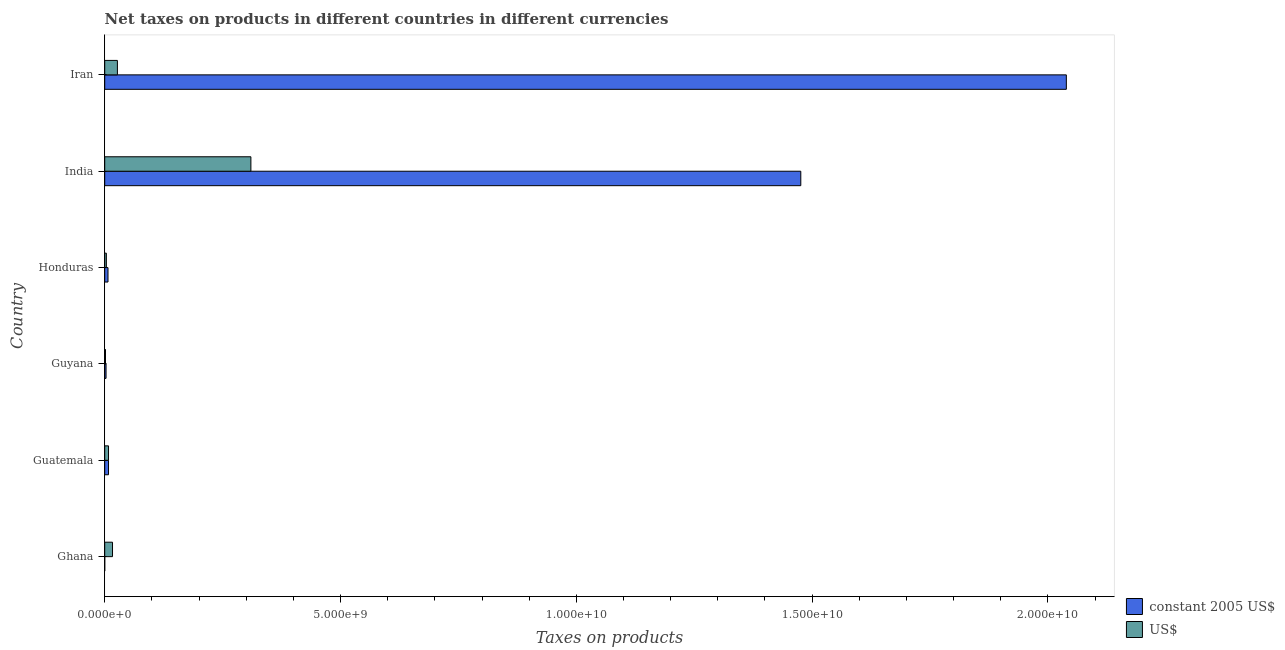How many different coloured bars are there?
Keep it short and to the point. 2. How many groups of bars are there?
Your answer should be very brief. 6. Are the number of bars per tick equal to the number of legend labels?
Provide a succinct answer. Yes. How many bars are there on the 5th tick from the top?
Provide a short and direct response. 2. What is the label of the 5th group of bars from the top?
Ensure brevity in your answer.  Guatemala. In how many cases, is the number of bars for a given country not equal to the number of legend labels?
Offer a terse response. 0. What is the net taxes in constant 2005 us$ in Ghana?
Provide a succinct answer. 1.18e+04. Across all countries, what is the maximum net taxes in us$?
Provide a succinct answer. 3.10e+09. Across all countries, what is the minimum net taxes in constant 2005 us$?
Your response must be concise. 1.18e+04. In which country was the net taxes in constant 2005 us$ maximum?
Your response must be concise. Iran. In which country was the net taxes in constant 2005 us$ minimum?
Offer a terse response. Ghana. What is the total net taxes in us$ in the graph?
Make the answer very short. 3.67e+09. What is the difference between the net taxes in constant 2005 us$ in Ghana and that in Honduras?
Your answer should be very brief. -6.96e+07. What is the difference between the net taxes in us$ in Guatemala and the net taxes in constant 2005 us$ in Guyana?
Ensure brevity in your answer.  5.24e+07. What is the average net taxes in constant 2005 us$ per country?
Your answer should be very brief. 5.89e+09. What is the difference between the net taxes in constant 2005 us$ and net taxes in us$ in Guyana?
Offer a very short reply. 1.18e+07. In how many countries, is the net taxes in constant 2005 us$ greater than 19000000000 units?
Provide a short and direct response. 1. What is the ratio of the net taxes in us$ in Guatemala to that in Honduras?
Keep it short and to the point. 2.32. Is the net taxes in us$ in Ghana less than that in Guyana?
Provide a short and direct response. No. What is the difference between the highest and the second highest net taxes in constant 2005 us$?
Provide a succinct answer. 5.63e+09. What is the difference between the highest and the lowest net taxes in us$?
Your answer should be very brief. 3.08e+09. In how many countries, is the net taxes in constant 2005 us$ greater than the average net taxes in constant 2005 us$ taken over all countries?
Your answer should be compact. 2. What does the 2nd bar from the top in Guatemala represents?
Offer a very short reply. Constant 2005 us$. What does the 2nd bar from the bottom in Honduras represents?
Offer a very short reply. US$. How many bars are there?
Your answer should be very brief. 12. Are all the bars in the graph horizontal?
Your response must be concise. Yes. Are the values on the major ticks of X-axis written in scientific E-notation?
Make the answer very short. Yes. Does the graph contain any zero values?
Your answer should be very brief. No. Does the graph contain grids?
Ensure brevity in your answer.  No. Where does the legend appear in the graph?
Keep it short and to the point. Bottom right. How many legend labels are there?
Offer a very short reply. 2. What is the title of the graph?
Make the answer very short. Net taxes on products in different countries in different currencies. What is the label or title of the X-axis?
Ensure brevity in your answer.  Taxes on products. What is the label or title of the Y-axis?
Your answer should be very brief. Country. What is the Taxes on products in constant 2005 US$ in Ghana?
Ensure brevity in your answer.  1.18e+04. What is the Taxes on products in US$ in Ghana?
Your answer should be very brief. 1.65e+08. What is the Taxes on products in constant 2005 US$ in Guatemala?
Provide a short and direct response. 8.06e+07. What is the Taxes on products in US$ in Guatemala?
Your response must be concise. 8.06e+07. What is the Taxes on products of constant 2005 US$ in Guyana?
Make the answer very short. 2.82e+07. What is the Taxes on products in US$ in Guyana?
Give a very brief answer. 1.64e+07. What is the Taxes on products in constant 2005 US$ in Honduras?
Make the answer very short. 6.96e+07. What is the Taxes on products in US$ in Honduras?
Offer a very short reply. 3.48e+07. What is the Taxes on products in constant 2005 US$ in India?
Provide a succinct answer. 1.48e+1. What is the Taxes on products of US$ in India?
Keep it short and to the point. 3.10e+09. What is the Taxes on products in constant 2005 US$ in Iran?
Provide a succinct answer. 2.04e+1. What is the Taxes on products in US$ in Iran?
Make the answer very short. 2.69e+08. Across all countries, what is the maximum Taxes on products of constant 2005 US$?
Keep it short and to the point. 2.04e+1. Across all countries, what is the maximum Taxes on products of US$?
Offer a terse response. 3.10e+09. Across all countries, what is the minimum Taxes on products in constant 2005 US$?
Give a very brief answer. 1.18e+04. Across all countries, what is the minimum Taxes on products in US$?
Your response must be concise. 1.64e+07. What is the total Taxes on products in constant 2005 US$ in the graph?
Ensure brevity in your answer.  3.53e+1. What is the total Taxes on products in US$ in the graph?
Provide a short and direct response. 3.67e+09. What is the difference between the Taxes on products in constant 2005 US$ in Ghana and that in Guatemala?
Your response must be concise. -8.06e+07. What is the difference between the Taxes on products in US$ in Ghana and that in Guatemala?
Make the answer very short. 8.47e+07. What is the difference between the Taxes on products of constant 2005 US$ in Ghana and that in Guyana?
Provide a short and direct response. -2.82e+07. What is the difference between the Taxes on products in US$ in Ghana and that in Guyana?
Offer a very short reply. 1.49e+08. What is the difference between the Taxes on products in constant 2005 US$ in Ghana and that in Honduras?
Keep it short and to the point. -6.96e+07. What is the difference between the Taxes on products of US$ in Ghana and that in Honduras?
Your response must be concise. 1.30e+08. What is the difference between the Taxes on products in constant 2005 US$ in Ghana and that in India?
Ensure brevity in your answer.  -1.48e+1. What is the difference between the Taxes on products of US$ in Ghana and that in India?
Give a very brief answer. -2.93e+09. What is the difference between the Taxes on products of constant 2005 US$ in Ghana and that in Iran?
Provide a short and direct response. -2.04e+1. What is the difference between the Taxes on products of US$ in Ghana and that in Iran?
Provide a succinct answer. -1.04e+08. What is the difference between the Taxes on products in constant 2005 US$ in Guatemala and that in Guyana?
Your answer should be compact. 5.24e+07. What is the difference between the Taxes on products of US$ in Guatemala and that in Guyana?
Your answer should be very brief. 6.42e+07. What is the difference between the Taxes on products in constant 2005 US$ in Guatemala and that in Honduras?
Ensure brevity in your answer.  1.10e+07. What is the difference between the Taxes on products of US$ in Guatemala and that in Honduras?
Offer a very short reply. 4.58e+07. What is the difference between the Taxes on products in constant 2005 US$ in Guatemala and that in India?
Provide a short and direct response. -1.47e+1. What is the difference between the Taxes on products in US$ in Guatemala and that in India?
Ensure brevity in your answer.  -3.02e+09. What is the difference between the Taxes on products of constant 2005 US$ in Guatemala and that in Iran?
Ensure brevity in your answer.  -2.03e+1. What is the difference between the Taxes on products of US$ in Guatemala and that in Iran?
Provide a succinct answer. -1.89e+08. What is the difference between the Taxes on products in constant 2005 US$ in Guyana and that in Honduras?
Offer a terse response. -4.14e+07. What is the difference between the Taxes on products in US$ in Guyana and that in Honduras?
Your answer should be very brief. -1.84e+07. What is the difference between the Taxes on products of constant 2005 US$ in Guyana and that in India?
Your answer should be very brief. -1.47e+1. What is the difference between the Taxes on products in US$ in Guyana and that in India?
Offer a very short reply. -3.08e+09. What is the difference between the Taxes on products of constant 2005 US$ in Guyana and that in Iran?
Make the answer very short. -2.04e+1. What is the difference between the Taxes on products in US$ in Guyana and that in Iran?
Offer a very short reply. -2.53e+08. What is the difference between the Taxes on products in constant 2005 US$ in Honduras and that in India?
Offer a terse response. -1.47e+1. What is the difference between the Taxes on products of US$ in Honduras and that in India?
Give a very brief answer. -3.06e+09. What is the difference between the Taxes on products in constant 2005 US$ in Honduras and that in Iran?
Offer a very short reply. -2.03e+1. What is the difference between the Taxes on products in US$ in Honduras and that in Iran?
Ensure brevity in your answer.  -2.34e+08. What is the difference between the Taxes on products of constant 2005 US$ in India and that in Iran?
Your response must be concise. -5.63e+09. What is the difference between the Taxes on products in US$ in India and that in Iran?
Make the answer very short. 2.83e+09. What is the difference between the Taxes on products of constant 2005 US$ in Ghana and the Taxes on products of US$ in Guatemala?
Make the answer very short. -8.06e+07. What is the difference between the Taxes on products of constant 2005 US$ in Ghana and the Taxes on products of US$ in Guyana?
Keep it short and to the point. -1.64e+07. What is the difference between the Taxes on products in constant 2005 US$ in Ghana and the Taxes on products in US$ in Honduras?
Offer a terse response. -3.48e+07. What is the difference between the Taxes on products in constant 2005 US$ in Ghana and the Taxes on products in US$ in India?
Keep it short and to the point. -3.10e+09. What is the difference between the Taxes on products in constant 2005 US$ in Ghana and the Taxes on products in US$ in Iran?
Your answer should be very brief. -2.69e+08. What is the difference between the Taxes on products in constant 2005 US$ in Guatemala and the Taxes on products in US$ in Guyana?
Keep it short and to the point. 6.42e+07. What is the difference between the Taxes on products in constant 2005 US$ in Guatemala and the Taxes on products in US$ in Honduras?
Ensure brevity in your answer.  4.58e+07. What is the difference between the Taxes on products of constant 2005 US$ in Guatemala and the Taxes on products of US$ in India?
Your answer should be very brief. -3.02e+09. What is the difference between the Taxes on products of constant 2005 US$ in Guatemala and the Taxes on products of US$ in Iran?
Your response must be concise. -1.89e+08. What is the difference between the Taxes on products in constant 2005 US$ in Guyana and the Taxes on products in US$ in Honduras?
Provide a short and direct response. -6.60e+06. What is the difference between the Taxes on products of constant 2005 US$ in Guyana and the Taxes on products of US$ in India?
Give a very brief answer. -3.07e+09. What is the difference between the Taxes on products in constant 2005 US$ in Guyana and the Taxes on products in US$ in Iran?
Provide a succinct answer. -2.41e+08. What is the difference between the Taxes on products in constant 2005 US$ in Honduras and the Taxes on products in US$ in India?
Offer a very short reply. -3.03e+09. What is the difference between the Taxes on products in constant 2005 US$ in Honduras and the Taxes on products in US$ in Iran?
Provide a succinct answer. -2.00e+08. What is the difference between the Taxes on products in constant 2005 US$ in India and the Taxes on products in US$ in Iran?
Keep it short and to the point. 1.45e+1. What is the average Taxes on products of constant 2005 US$ per country?
Keep it short and to the point. 5.89e+09. What is the average Taxes on products in US$ per country?
Your answer should be compact. 6.11e+08. What is the difference between the Taxes on products in constant 2005 US$ and Taxes on products in US$ in Ghana?
Your answer should be very brief. -1.65e+08. What is the difference between the Taxes on products of constant 2005 US$ and Taxes on products of US$ in Guatemala?
Provide a succinct answer. 0. What is the difference between the Taxes on products of constant 2005 US$ and Taxes on products of US$ in Guyana?
Make the answer very short. 1.18e+07. What is the difference between the Taxes on products in constant 2005 US$ and Taxes on products in US$ in Honduras?
Keep it short and to the point. 3.48e+07. What is the difference between the Taxes on products of constant 2005 US$ and Taxes on products of US$ in India?
Ensure brevity in your answer.  1.17e+1. What is the difference between the Taxes on products of constant 2005 US$ and Taxes on products of US$ in Iran?
Ensure brevity in your answer.  2.01e+1. What is the ratio of the Taxes on products of constant 2005 US$ in Ghana to that in Guatemala?
Give a very brief answer. 0. What is the ratio of the Taxes on products of US$ in Ghana to that in Guatemala?
Your answer should be compact. 2.05. What is the ratio of the Taxes on products of US$ in Ghana to that in Guyana?
Make the answer very short. 10.05. What is the ratio of the Taxes on products in constant 2005 US$ in Ghana to that in Honduras?
Your answer should be compact. 0. What is the ratio of the Taxes on products of US$ in Ghana to that in Honduras?
Make the answer very short. 4.75. What is the ratio of the Taxes on products of constant 2005 US$ in Ghana to that in India?
Ensure brevity in your answer.  0. What is the ratio of the Taxes on products of US$ in Ghana to that in India?
Ensure brevity in your answer.  0.05. What is the ratio of the Taxes on products of US$ in Ghana to that in Iran?
Offer a very short reply. 0.61. What is the ratio of the Taxes on products in constant 2005 US$ in Guatemala to that in Guyana?
Keep it short and to the point. 2.86. What is the ratio of the Taxes on products in US$ in Guatemala to that in Guyana?
Ensure brevity in your answer.  4.9. What is the ratio of the Taxes on products of constant 2005 US$ in Guatemala to that in Honduras?
Provide a short and direct response. 1.16. What is the ratio of the Taxes on products of US$ in Guatemala to that in Honduras?
Your answer should be very brief. 2.32. What is the ratio of the Taxes on products in constant 2005 US$ in Guatemala to that in India?
Keep it short and to the point. 0.01. What is the ratio of the Taxes on products of US$ in Guatemala to that in India?
Make the answer very short. 0.03. What is the ratio of the Taxes on products in constant 2005 US$ in Guatemala to that in Iran?
Offer a terse response. 0. What is the ratio of the Taxes on products of US$ in Guatemala to that in Iran?
Provide a succinct answer. 0.3. What is the ratio of the Taxes on products of constant 2005 US$ in Guyana to that in Honduras?
Your response must be concise. 0.41. What is the ratio of the Taxes on products in US$ in Guyana to that in Honduras?
Provide a succinct answer. 0.47. What is the ratio of the Taxes on products of constant 2005 US$ in Guyana to that in India?
Offer a terse response. 0. What is the ratio of the Taxes on products in US$ in Guyana to that in India?
Make the answer very short. 0.01. What is the ratio of the Taxes on products in constant 2005 US$ in Guyana to that in Iran?
Give a very brief answer. 0. What is the ratio of the Taxes on products in US$ in Guyana to that in Iran?
Offer a very short reply. 0.06. What is the ratio of the Taxes on products of constant 2005 US$ in Honduras to that in India?
Provide a succinct answer. 0. What is the ratio of the Taxes on products of US$ in Honduras to that in India?
Provide a succinct answer. 0.01. What is the ratio of the Taxes on products of constant 2005 US$ in Honduras to that in Iran?
Provide a succinct answer. 0. What is the ratio of the Taxes on products in US$ in Honduras to that in Iran?
Your answer should be compact. 0.13. What is the ratio of the Taxes on products of constant 2005 US$ in India to that in Iran?
Your response must be concise. 0.72. What is the ratio of the Taxes on products of US$ in India to that in Iran?
Offer a very short reply. 11.51. What is the difference between the highest and the second highest Taxes on products of constant 2005 US$?
Offer a terse response. 5.63e+09. What is the difference between the highest and the second highest Taxes on products in US$?
Offer a terse response. 2.83e+09. What is the difference between the highest and the lowest Taxes on products in constant 2005 US$?
Give a very brief answer. 2.04e+1. What is the difference between the highest and the lowest Taxes on products of US$?
Provide a succinct answer. 3.08e+09. 